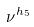<formula> <loc_0><loc_0><loc_500><loc_500>\nu ^ { h _ { 5 } }</formula> 